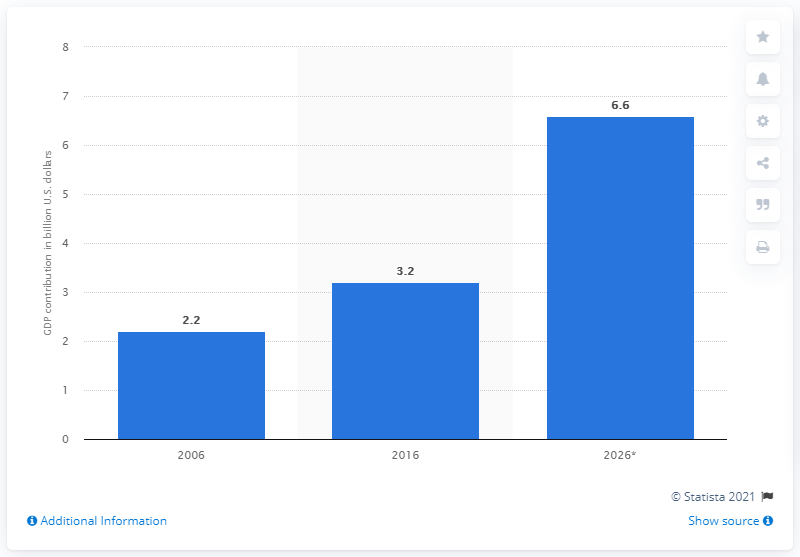Highlight a few significant elements in this photo. In 2026, the direct tourism contribution of Mecca to the GDP of Saudi Arabia was estimated to be 6.6%. 